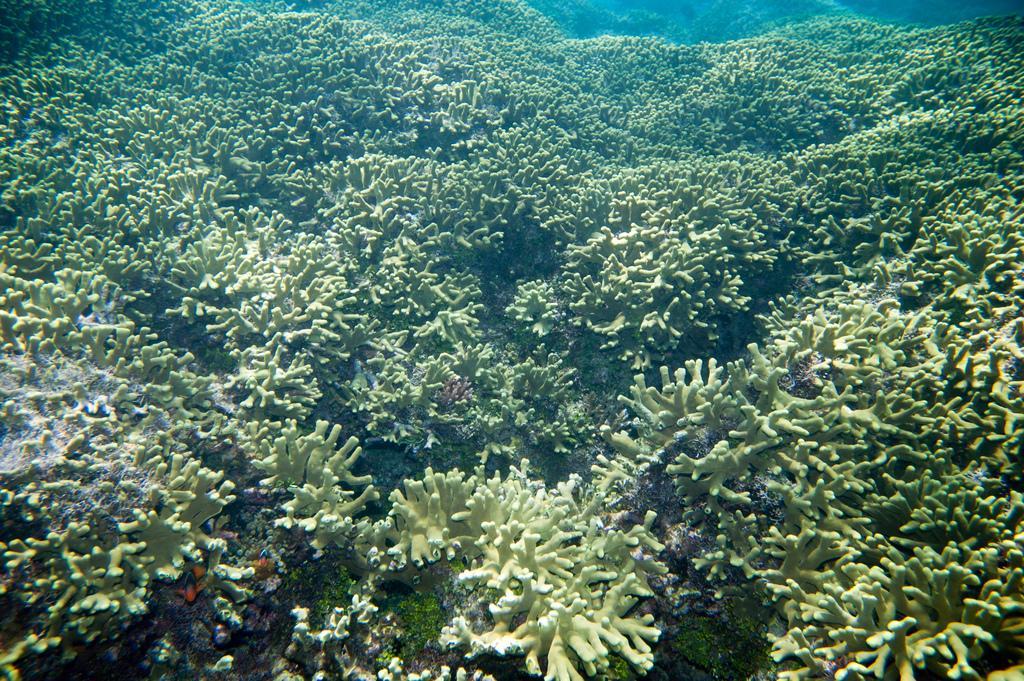How would you summarize this image in a sentence or two? In this image I can see few aquatic plants and the plants are in green color. 